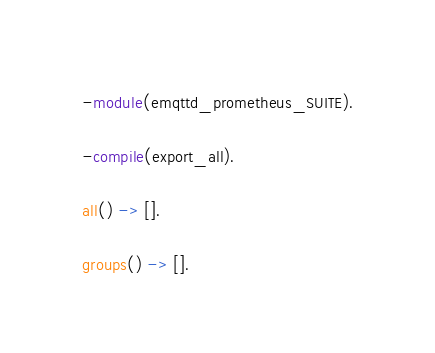<code> <loc_0><loc_0><loc_500><loc_500><_Erlang_>
-module(emqttd_prometheus_SUITE).

-compile(export_all).

all() -> [].

groups() -> [].
</code> 